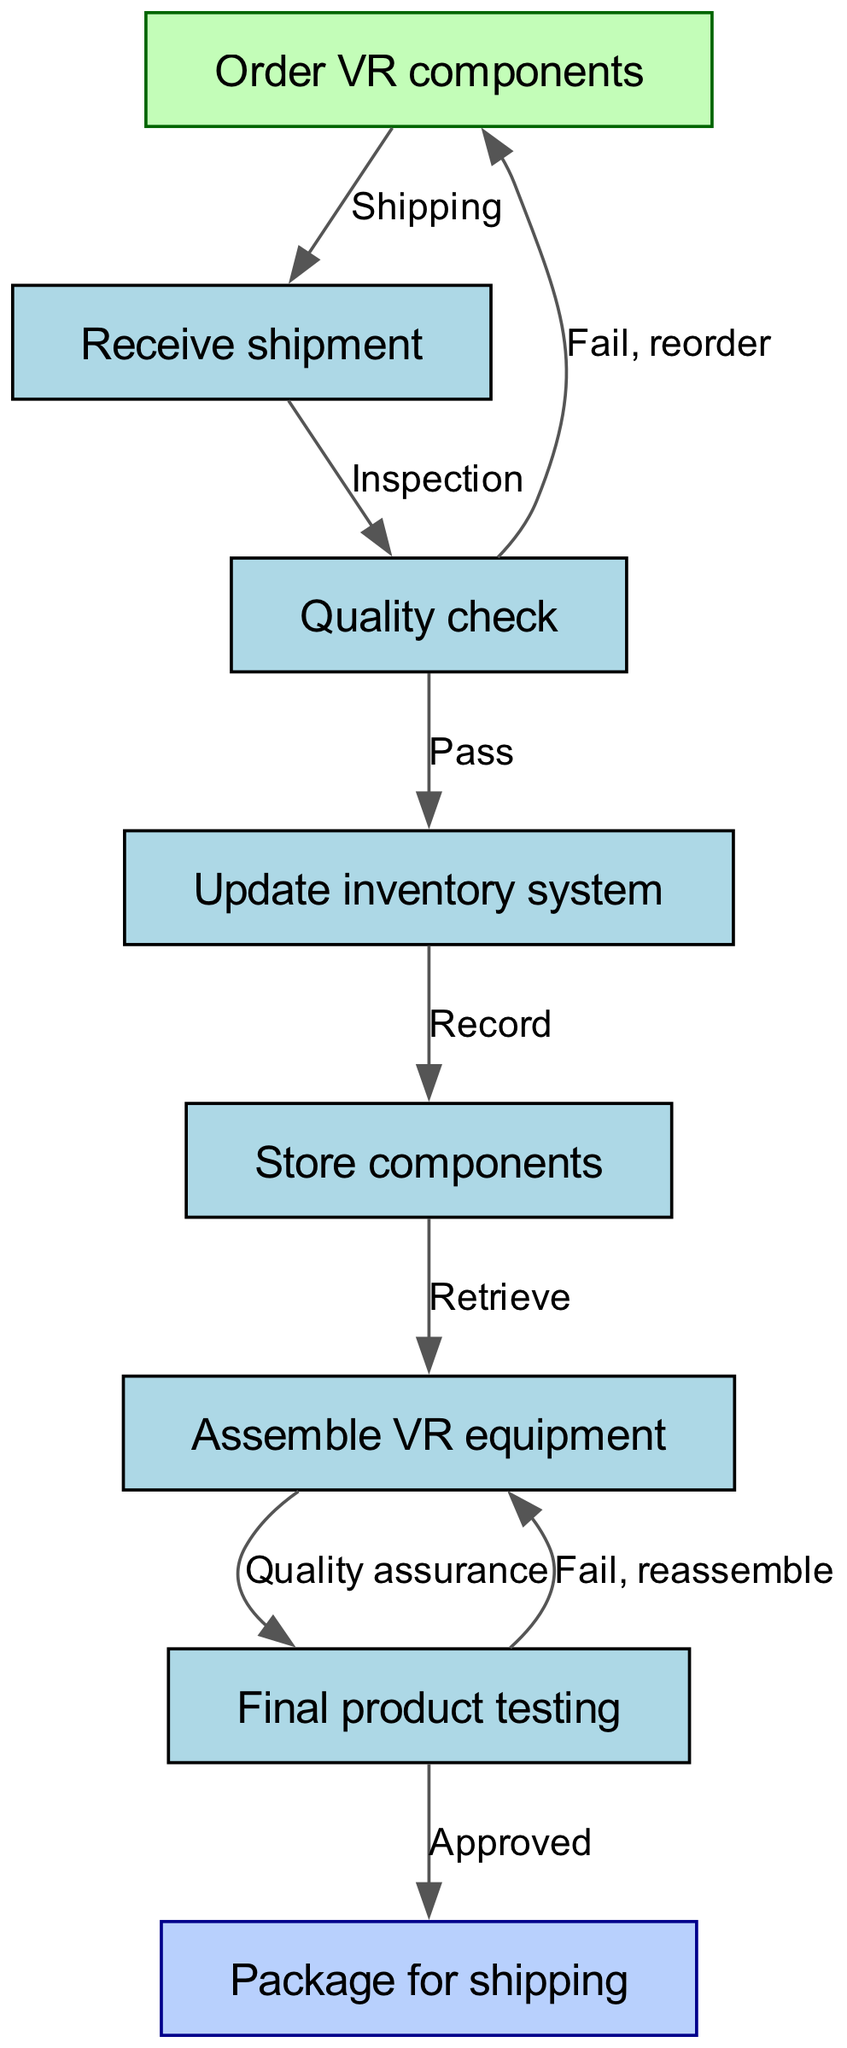What is the first step in the flow chart? The first step is represented by node "1", which states "Order VR components." This is indicated as the starting point of the supply chain process.
Answer: Order VR components How many components are there in the inventory update process? The inventory update process involves nodes "4" (Update inventory system), "5" (Store components), and node "6" (Assemble VR equipment), making a total of three components.
Answer: Three What happens if the quality check fails? If the quality check fails (node "3"), the flow indicates a loop back to node "1" for reordering components as per the edge labeled "Fail, reorder."
Answer: Reorder What is the relationship between the final product testing and packaging? The final product testing (node "7") is connected to packaging (node "8") through an approved transition, represented by the edge labeled "Approved." This indicates that only tested and approved products can proceed to packaging.
Answer: Approved What is the total number of nodes in the flow chart? There are eight nodes in total, as seen in the "nodes" section of the diagram data. They represent different steps in the supply chain management process for VR components.
Answer: Eight What step follows the assembly of VR equipment? After assembling VR equipment (node "6"), the next step is the final product testing, as indicated by the edge connecting node "6" to node "7" labeled "Quality assurance."
Answer: Final product testing 